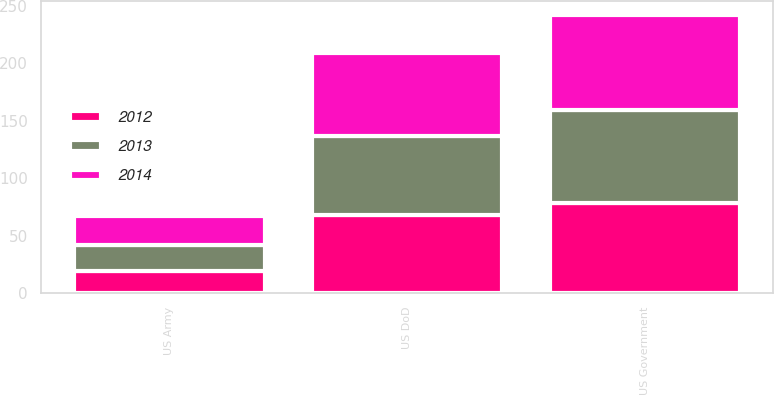<chart> <loc_0><loc_0><loc_500><loc_500><stacked_bar_chart><ecel><fcel>US Government<fcel>US DoD<fcel>US Army<nl><fcel>2012<fcel>78<fcel>68<fcel>19<nl><fcel>2013<fcel>81<fcel>69<fcel>23<nl><fcel>2014<fcel>83<fcel>72<fcel>25<nl></chart> 